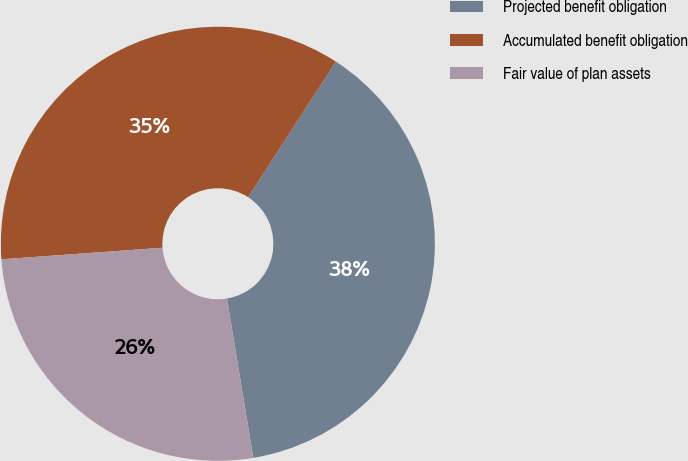<chart> <loc_0><loc_0><loc_500><loc_500><pie_chart><fcel>Projected benefit obligation<fcel>Accumulated benefit obligation<fcel>Fair value of plan assets<nl><fcel>38.24%<fcel>35.29%<fcel>26.47%<nl></chart> 